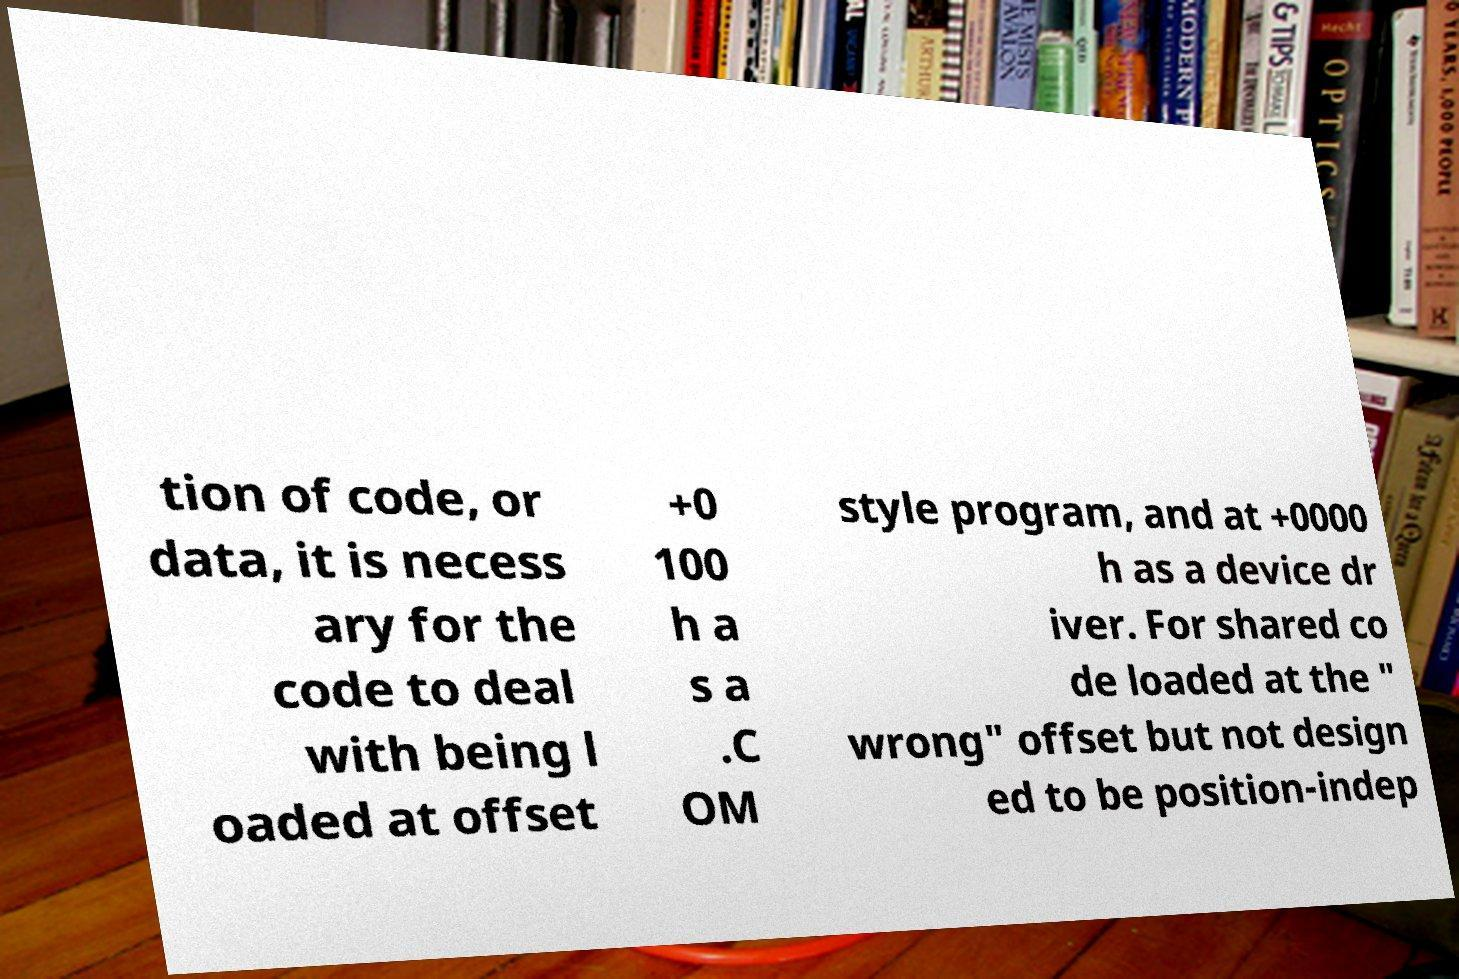I need the written content from this picture converted into text. Can you do that? tion of code, or data, it is necess ary for the code to deal with being l oaded at offset +0 100 h a s a .C OM style program, and at +0000 h as a device dr iver. For shared co de loaded at the " wrong" offset but not design ed to be position-indep 